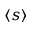Convert formula to latex. <formula><loc_0><loc_0><loc_500><loc_500>\langle s \rangle</formula> 